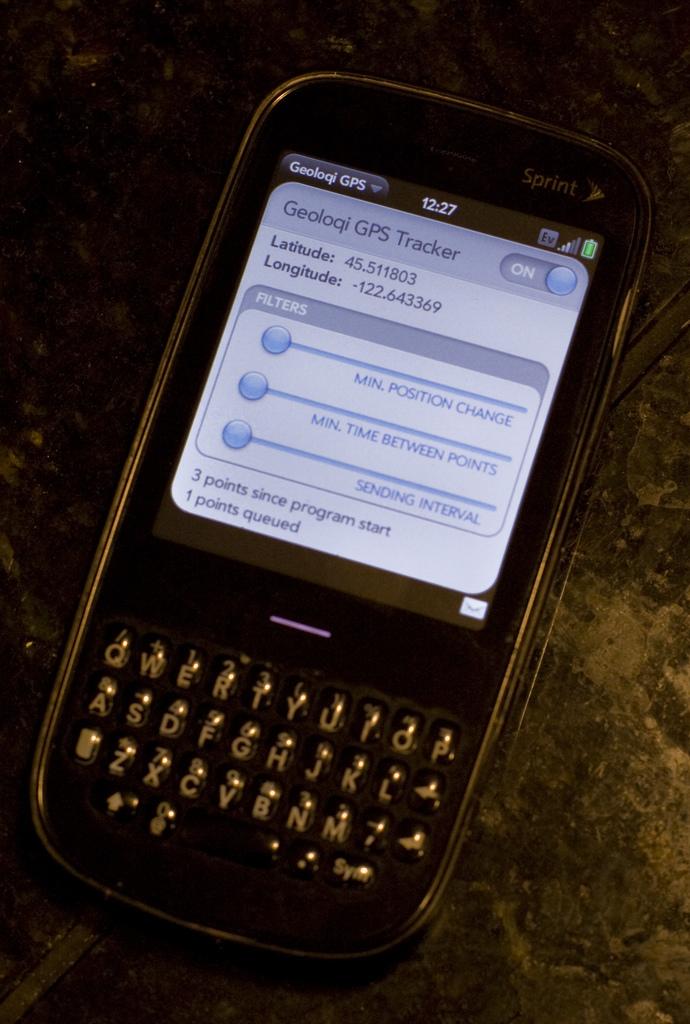What time is it?
Provide a succinct answer. 12:27. Is the gps tracker on or off?
Ensure brevity in your answer.  On. 